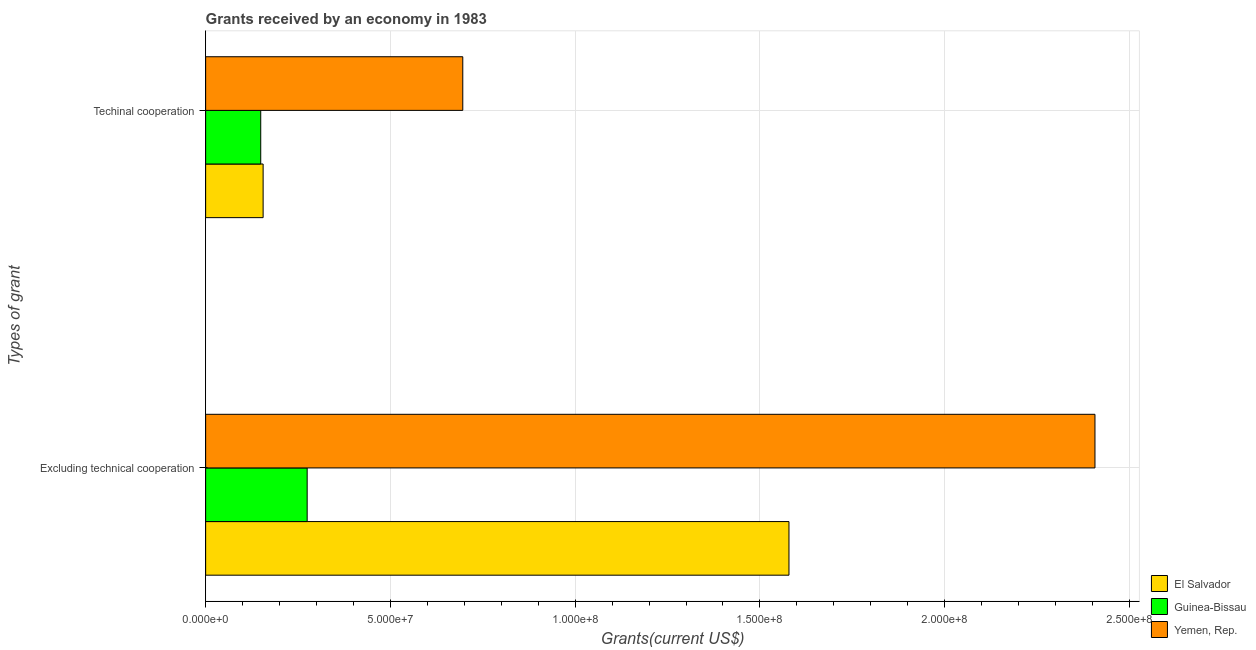How many different coloured bars are there?
Your answer should be compact. 3. What is the label of the 2nd group of bars from the top?
Ensure brevity in your answer.  Excluding technical cooperation. What is the amount of grants received(including technical cooperation) in Guinea-Bissau?
Your answer should be very brief. 1.49e+07. Across all countries, what is the maximum amount of grants received(excluding technical cooperation)?
Give a very brief answer. 2.41e+08. Across all countries, what is the minimum amount of grants received(excluding technical cooperation)?
Make the answer very short. 2.75e+07. In which country was the amount of grants received(excluding technical cooperation) maximum?
Offer a terse response. Yemen, Rep. In which country was the amount of grants received(including technical cooperation) minimum?
Provide a succinct answer. Guinea-Bissau. What is the total amount of grants received(including technical cooperation) in the graph?
Your answer should be very brief. 1.00e+08. What is the difference between the amount of grants received(excluding technical cooperation) in Yemen, Rep. and that in El Salvador?
Provide a succinct answer. 8.28e+07. What is the difference between the amount of grants received(including technical cooperation) in Yemen, Rep. and the amount of grants received(excluding technical cooperation) in El Salvador?
Your response must be concise. -8.83e+07. What is the average amount of grants received(excluding technical cooperation) per country?
Provide a succinct answer. 1.42e+08. What is the difference between the amount of grants received(excluding technical cooperation) and amount of grants received(including technical cooperation) in Yemen, Rep.?
Keep it short and to the point. 1.71e+08. What is the ratio of the amount of grants received(excluding technical cooperation) in Yemen, Rep. to that in El Salvador?
Your response must be concise. 1.52. Is the amount of grants received(including technical cooperation) in Guinea-Bissau less than that in El Salvador?
Your response must be concise. Yes. What does the 2nd bar from the top in Excluding technical cooperation represents?
Provide a succinct answer. Guinea-Bissau. What does the 1st bar from the bottom in Techinal cooperation represents?
Provide a succinct answer. El Salvador. How many bars are there?
Your answer should be compact. 6. Are all the bars in the graph horizontal?
Offer a terse response. Yes. What is the difference between two consecutive major ticks on the X-axis?
Make the answer very short. 5.00e+07. Are the values on the major ticks of X-axis written in scientific E-notation?
Your response must be concise. Yes. Does the graph contain any zero values?
Provide a succinct answer. No. Does the graph contain grids?
Provide a short and direct response. Yes. Where does the legend appear in the graph?
Ensure brevity in your answer.  Bottom right. How many legend labels are there?
Keep it short and to the point. 3. What is the title of the graph?
Ensure brevity in your answer.  Grants received by an economy in 1983. What is the label or title of the X-axis?
Offer a terse response. Grants(current US$). What is the label or title of the Y-axis?
Provide a short and direct response. Types of grant. What is the Grants(current US$) of El Salvador in Excluding technical cooperation?
Keep it short and to the point. 1.58e+08. What is the Grants(current US$) in Guinea-Bissau in Excluding technical cooperation?
Keep it short and to the point. 2.75e+07. What is the Grants(current US$) in Yemen, Rep. in Excluding technical cooperation?
Give a very brief answer. 2.41e+08. What is the Grants(current US$) in El Salvador in Techinal cooperation?
Your response must be concise. 1.56e+07. What is the Grants(current US$) in Guinea-Bissau in Techinal cooperation?
Your response must be concise. 1.49e+07. What is the Grants(current US$) of Yemen, Rep. in Techinal cooperation?
Your answer should be very brief. 6.96e+07. Across all Types of grant, what is the maximum Grants(current US$) in El Salvador?
Your answer should be compact. 1.58e+08. Across all Types of grant, what is the maximum Grants(current US$) of Guinea-Bissau?
Your answer should be compact. 2.75e+07. Across all Types of grant, what is the maximum Grants(current US$) of Yemen, Rep.?
Offer a terse response. 2.41e+08. Across all Types of grant, what is the minimum Grants(current US$) of El Salvador?
Your answer should be compact. 1.56e+07. Across all Types of grant, what is the minimum Grants(current US$) of Guinea-Bissau?
Make the answer very short. 1.49e+07. Across all Types of grant, what is the minimum Grants(current US$) in Yemen, Rep.?
Your answer should be compact. 6.96e+07. What is the total Grants(current US$) in El Salvador in the graph?
Offer a terse response. 1.73e+08. What is the total Grants(current US$) in Guinea-Bissau in the graph?
Your answer should be very brief. 4.24e+07. What is the total Grants(current US$) of Yemen, Rep. in the graph?
Offer a terse response. 3.10e+08. What is the difference between the Grants(current US$) of El Salvador in Excluding technical cooperation and that in Techinal cooperation?
Offer a terse response. 1.42e+08. What is the difference between the Grants(current US$) of Guinea-Bissau in Excluding technical cooperation and that in Techinal cooperation?
Provide a short and direct response. 1.26e+07. What is the difference between the Grants(current US$) in Yemen, Rep. in Excluding technical cooperation and that in Techinal cooperation?
Ensure brevity in your answer.  1.71e+08. What is the difference between the Grants(current US$) in El Salvador in Excluding technical cooperation and the Grants(current US$) in Guinea-Bissau in Techinal cooperation?
Ensure brevity in your answer.  1.43e+08. What is the difference between the Grants(current US$) in El Salvador in Excluding technical cooperation and the Grants(current US$) in Yemen, Rep. in Techinal cooperation?
Offer a terse response. 8.83e+07. What is the difference between the Grants(current US$) of Guinea-Bissau in Excluding technical cooperation and the Grants(current US$) of Yemen, Rep. in Techinal cooperation?
Keep it short and to the point. -4.21e+07. What is the average Grants(current US$) of El Salvador per Types of grant?
Offer a very short reply. 8.67e+07. What is the average Grants(current US$) in Guinea-Bissau per Types of grant?
Make the answer very short. 2.12e+07. What is the average Grants(current US$) of Yemen, Rep. per Types of grant?
Ensure brevity in your answer.  1.55e+08. What is the difference between the Grants(current US$) of El Salvador and Grants(current US$) of Guinea-Bissau in Excluding technical cooperation?
Your answer should be compact. 1.30e+08. What is the difference between the Grants(current US$) of El Salvador and Grants(current US$) of Yemen, Rep. in Excluding technical cooperation?
Provide a succinct answer. -8.28e+07. What is the difference between the Grants(current US$) in Guinea-Bissau and Grants(current US$) in Yemen, Rep. in Excluding technical cooperation?
Your answer should be very brief. -2.13e+08. What is the difference between the Grants(current US$) in El Salvador and Grants(current US$) in Guinea-Bissau in Techinal cooperation?
Give a very brief answer. 6.50e+05. What is the difference between the Grants(current US$) of El Salvador and Grants(current US$) of Yemen, Rep. in Techinal cooperation?
Give a very brief answer. -5.40e+07. What is the difference between the Grants(current US$) in Guinea-Bissau and Grants(current US$) in Yemen, Rep. in Techinal cooperation?
Your response must be concise. -5.47e+07. What is the ratio of the Grants(current US$) in El Salvador in Excluding technical cooperation to that in Techinal cooperation?
Give a very brief answer. 10.15. What is the ratio of the Grants(current US$) of Guinea-Bissau in Excluding technical cooperation to that in Techinal cooperation?
Make the answer very short. 1.84. What is the ratio of the Grants(current US$) of Yemen, Rep. in Excluding technical cooperation to that in Techinal cooperation?
Provide a short and direct response. 3.46. What is the difference between the highest and the second highest Grants(current US$) of El Salvador?
Your response must be concise. 1.42e+08. What is the difference between the highest and the second highest Grants(current US$) in Guinea-Bissau?
Your response must be concise. 1.26e+07. What is the difference between the highest and the second highest Grants(current US$) in Yemen, Rep.?
Provide a succinct answer. 1.71e+08. What is the difference between the highest and the lowest Grants(current US$) in El Salvador?
Ensure brevity in your answer.  1.42e+08. What is the difference between the highest and the lowest Grants(current US$) of Guinea-Bissau?
Your answer should be compact. 1.26e+07. What is the difference between the highest and the lowest Grants(current US$) of Yemen, Rep.?
Your answer should be compact. 1.71e+08. 